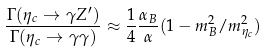<formula> <loc_0><loc_0><loc_500><loc_500>\frac { \Gamma ( \eta _ { c } \rightarrow \gamma Z ^ { \prime } ) } { \Gamma ( \eta _ { c } \rightarrow \gamma \gamma ) } \approx \frac { 1 } { 4 } \frac { \alpha _ { B } } { \alpha } ( 1 - m _ { B } ^ { 2 } / m ^ { 2 } _ { \eta _ { c } } )</formula> 